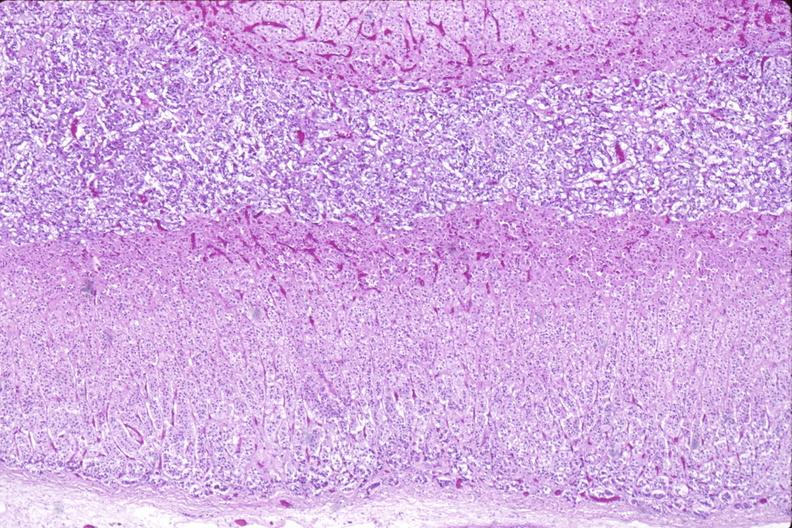does rocky mountain show adrenal gland, normal histology?
Answer the question using a single word or phrase. No 